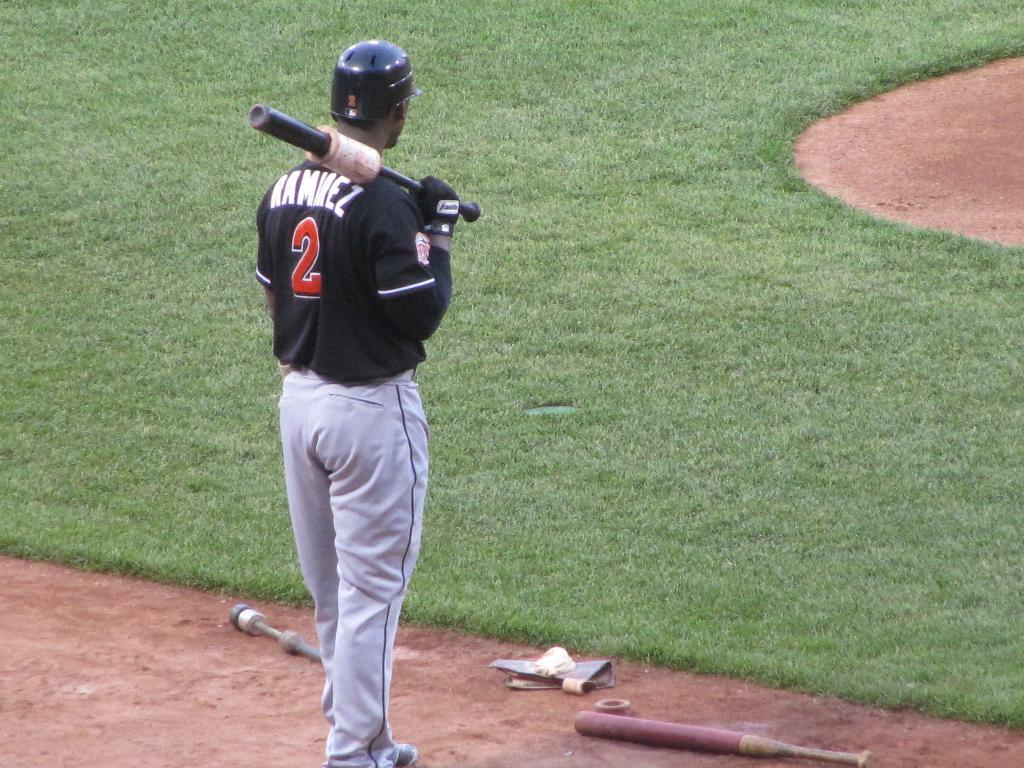<image>
Give a short and clear explanation of the subsequent image. a player that is wearing the number 2 